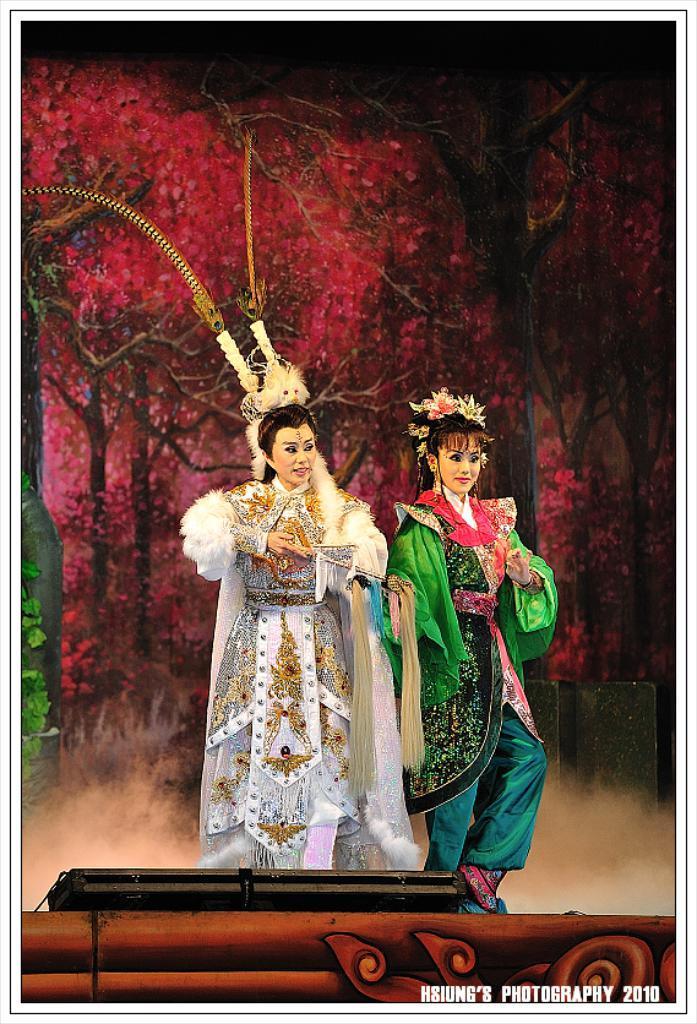Can you describe this image briefly? This is the picture of a place where we have two ladies with different costumes in white and green color and behind there are some trees which has some leaves. 